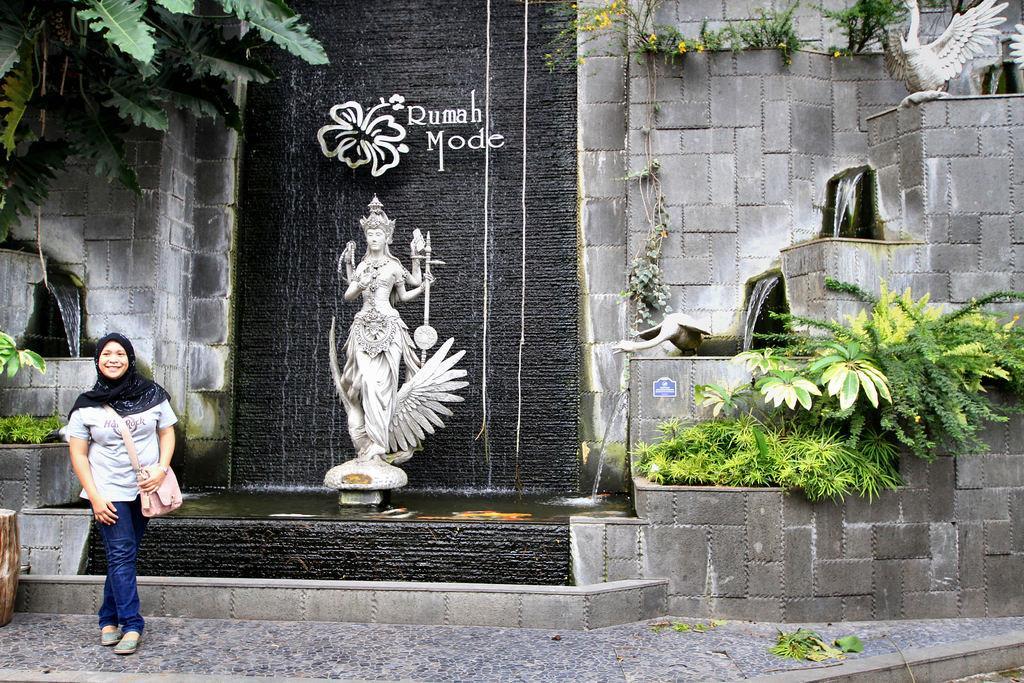Please provide a concise description of this image. In this image we can see there is a girl standing with a smile on her face, behind the girl there is a fountain. At the center of the fountain there is a statue, behind the statue there is some text. On the other sides of the fountain there are trees and plants. 